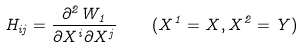Convert formula to latex. <formula><loc_0><loc_0><loc_500><loc_500>H _ { i j } = \frac { \partial ^ { 2 } W _ { 1 } } { \partial X ^ { i } \partial X ^ { j } } \quad ( X ^ { 1 } = X , X ^ { 2 } = Y )</formula> 